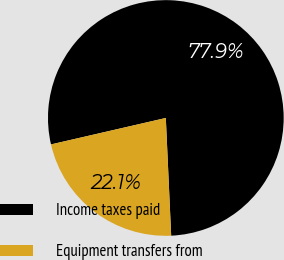Convert chart. <chart><loc_0><loc_0><loc_500><loc_500><pie_chart><fcel>Income taxes paid<fcel>Equipment transfers from<nl><fcel>77.88%<fcel>22.12%<nl></chart> 